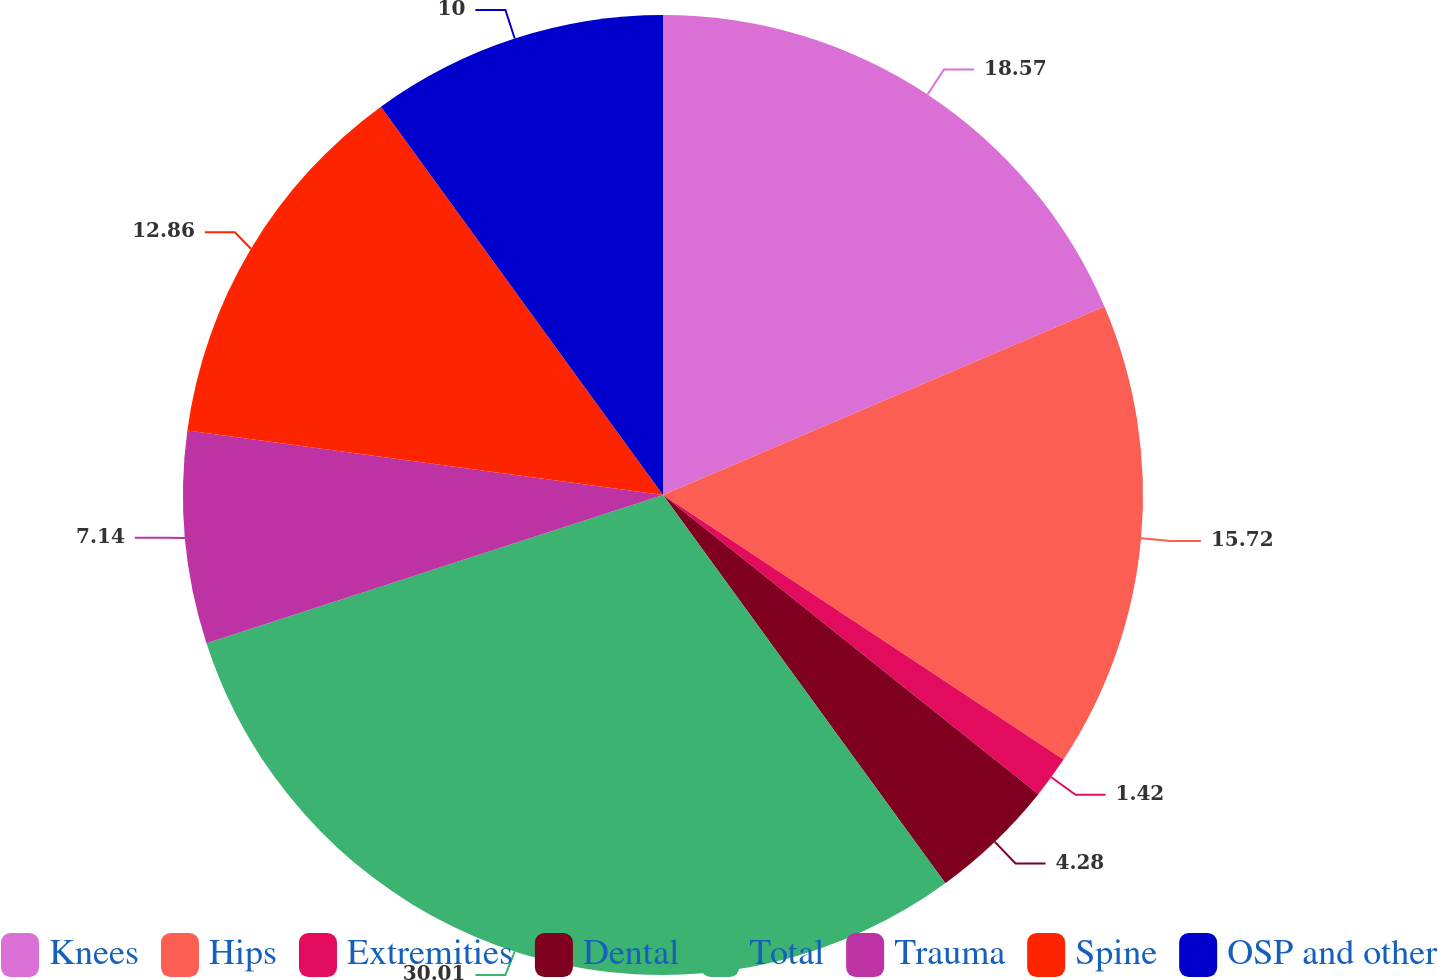<chart> <loc_0><loc_0><loc_500><loc_500><pie_chart><fcel>Knees<fcel>Hips<fcel>Extremities<fcel>Dental<fcel>Total<fcel>Trauma<fcel>Spine<fcel>OSP and other<nl><fcel>18.58%<fcel>15.72%<fcel>1.42%<fcel>4.28%<fcel>30.02%<fcel>7.14%<fcel>12.86%<fcel>10.0%<nl></chart> 